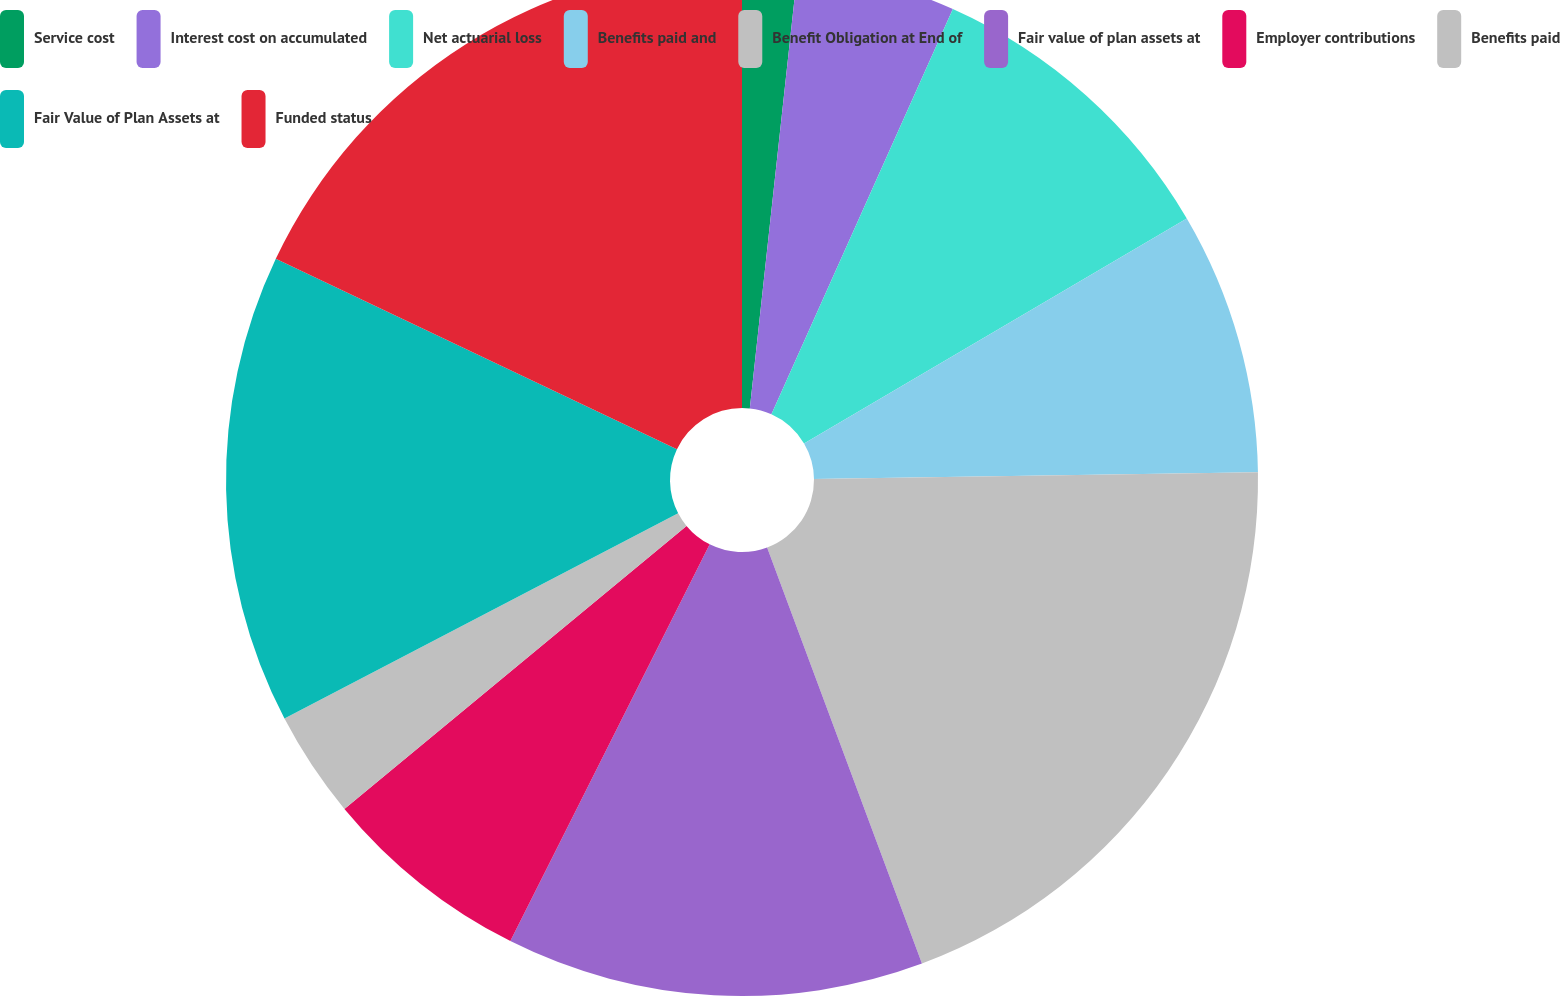<chart> <loc_0><loc_0><loc_500><loc_500><pie_chart><fcel>Service cost<fcel>Interest cost on accumulated<fcel>Net actuarial loss<fcel>Benefits paid and<fcel>Benefit Obligation at End of<fcel>Fair value of plan assets at<fcel>Employer contributions<fcel>Benefits paid<fcel>Fair Value of Plan Assets at<fcel>Funded status<nl><fcel>1.73%<fcel>4.97%<fcel>9.84%<fcel>8.22%<fcel>19.57%<fcel>13.08%<fcel>6.59%<fcel>3.35%<fcel>14.7%<fcel>17.95%<nl></chart> 